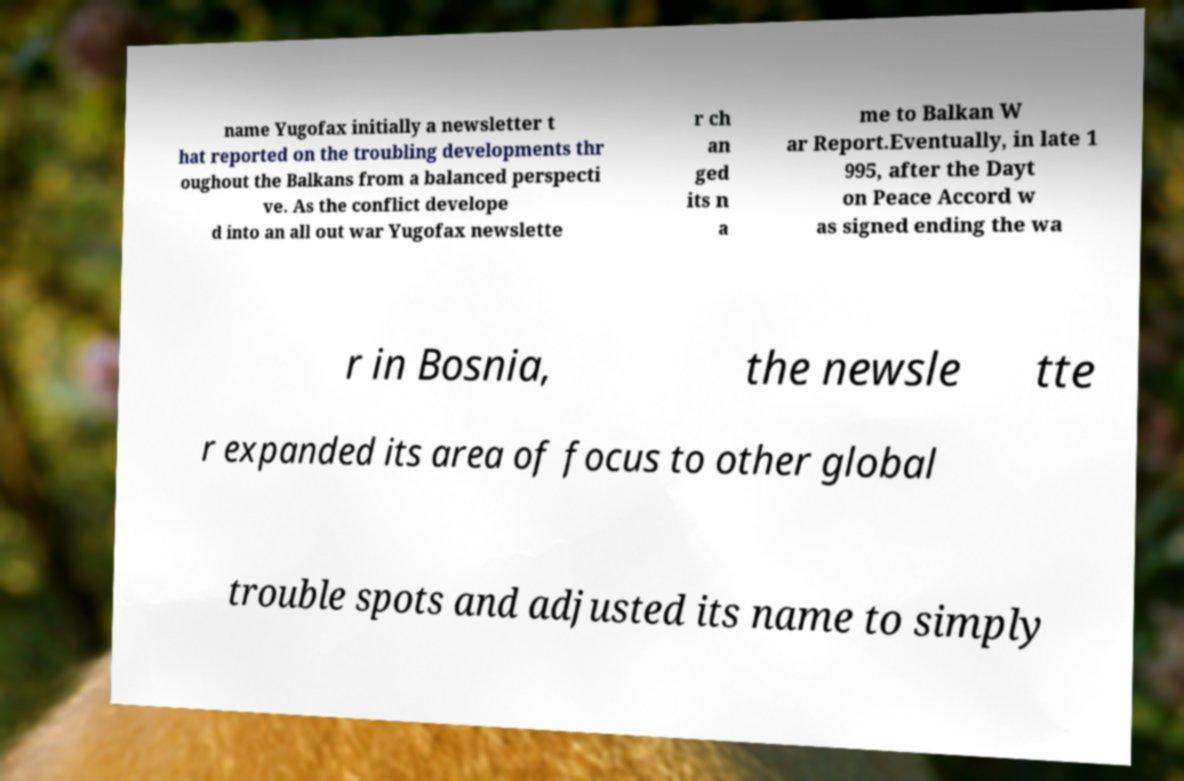There's text embedded in this image that I need extracted. Can you transcribe it verbatim? name Yugofax initially a newsletter t hat reported on the troubling developments thr oughout the Balkans from a balanced perspecti ve. As the conflict develope d into an all out war Yugofax newslette r ch an ged its n a me to Balkan W ar Report.Eventually, in late 1 995, after the Dayt on Peace Accord w as signed ending the wa r in Bosnia, the newsle tte r expanded its area of focus to other global trouble spots and adjusted its name to simply 